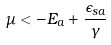<formula> <loc_0><loc_0><loc_500><loc_500>\mu < - E _ { a } + \frac { \epsilon _ { s a } } { \gamma }</formula> 